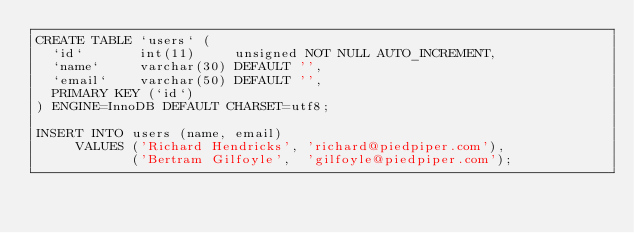<code> <loc_0><loc_0><loc_500><loc_500><_SQL_>CREATE TABLE `users` (
  `id`       int(11)     unsigned NOT NULL AUTO_INCREMENT,
  `name`     varchar(30) DEFAULT '',
  `email`    varchar(50) DEFAULT '',
  PRIMARY KEY (`id`)
) ENGINE=InnoDB DEFAULT CHARSET=utf8;

INSERT INTO users (name, email)
     VALUES ('Richard Hendricks', 'richard@piedpiper.com'),
            ('Bertram Gilfoyle',  'gilfoyle@piedpiper.com');
</code> 